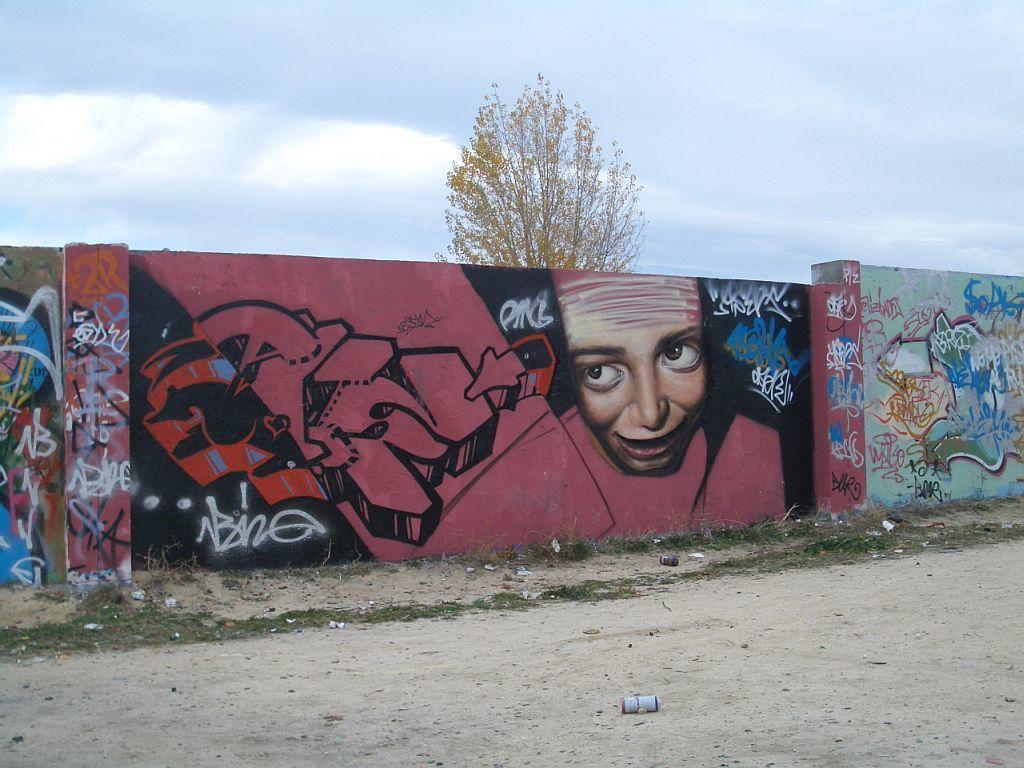Can you describe this image briefly? In the center of the image, we can see graffiti on the wall and there is a tree. At the bottom, we can see some objects and a bottle on the ground. At the top, there are clouds in the sky. 